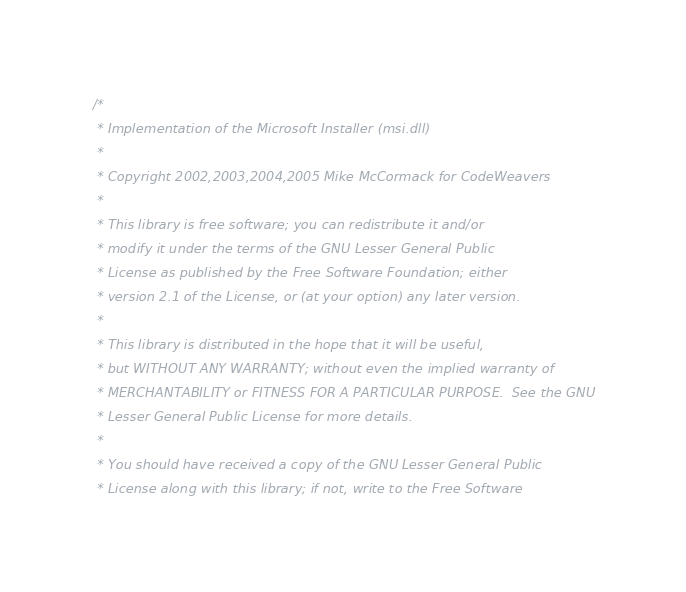<code> <loc_0><loc_0><loc_500><loc_500><_C_>/*
 * Implementation of the Microsoft Installer (msi.dll)
 *
 * Copyright 2002,2003,2004,2005 Mike McCormack for CodeWeavers
 *
 * This library is free software; you can redistribute it and/or
 * modify it under the terms of the GNU Lesser General Public
 * License as published by the Free Software Foundation; either
 * version 2.1 of the License, or (at your option) any later version.
 *
 * This library is distributed in the hope that it will be useful,
 * but WITHOUT ANY WARRANTY; without even the implied warranty of
 * MERCHANTABILITY or FITNESS FOR A PARTICULAR PURPOSE.  See the GNU
 * Lesser General Public License for more details.
 *
 * You should have received a copy of the GNU Lesser General Public
 * License along with this library; if not, write to the Free Software</code> 